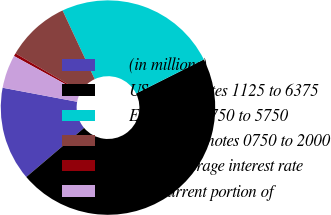Convert chart to OTSL. <chart><loc_0><loc_0><loc_500><loc_500><pie_chart><fcel>(in millions)<fcel>US dollar notes 1125 to 6375<fcel>Euro notes 1750 to 5750<fcel>Swiss franc notes 0750 to 2000<fcel>Other (average interest rate<fcel>Less current portion of<nl><fcel>14.17%<fcel>46.2%<fcel>24.56%<fcel>9.6%<fcel>0.45%<fcel>5.02%<nl></chart> 